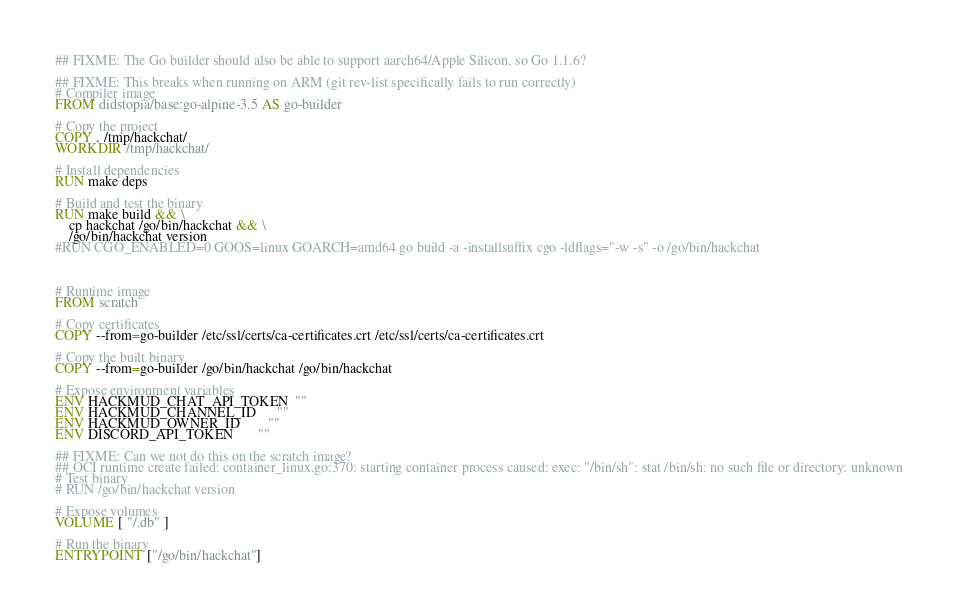<code> <loc_0><loc_0><loc_500><loc_500><_Dockerfile_>## FIXME: The Go builder should also be able to support aarch64/Apple Silicon, so Go 1.1.6?

## FIXME: This breaks when running on ARM (git rev-list specifically fails to run correctly)
# Compiler image
FROM didstopia/base:go-alpine-3.5 AS go-builder

# Copy the project 
COPY . /tmp/hackchat/
WORKDIR /tmp/hackchat/

# Install dependencies
RUN make deps

# Build and test the binary
RUN make build && \
    cp hackchat /go/bin/hackchat && \
    /go/bin/hackchat version
#RUN CGO_ENABLED=0 GOOS=linux GOARCH=amd64 go build -a -installsuffix cgo -ldflags="-w -s" -o /go/bin/hackchat



# Runtime image
FROM scratch

# Copy certificates
COPY --from=go-builder /etc/ssl/certs/ca-certificates.crt /etc/ssl/certs/ca-certificates.crt

# Copy the built binary
COPY --from=go-builder /go/bin/hackchat /go/bin/hackchat

# Expose environment variables
ENV HACKMUD_CHAT_API_TOKEN  ""
ENV HACKMUD_CHANNEL_ID      ""
ENV HACKMUD_OWNER_ID        ""
ENV DISCORD_API_TOKEN       ""

## FIXME: Can we not do this on the scratch image?
## OCI runtime create failed: container_linux.go:370: starting container process caused: exec: "/bin/sh": stat /bin/sh: no such file or directory: unknown
# Test binary
# RUN /go/bin/hackchat version

# Expose volumes
VOLUME [ "/.db" ]

# Run the binary
ENTRYPOINT ["/go/bin/hackchat"]
</code> 